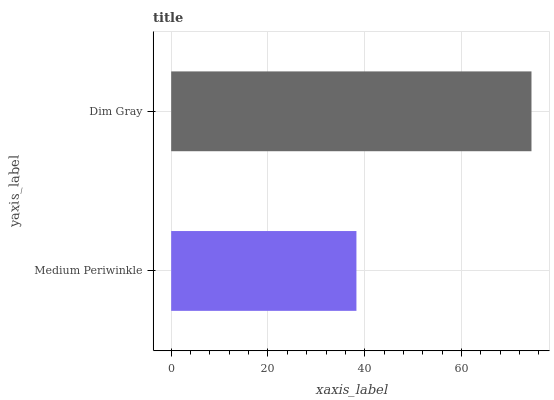Is Medium Periwinkle the minimum?
Answer yes or no. Yes. Is Dim Gray the maximum?
Answer yes or no. Yes. Is Dim Gray the minimum?
Answer yes or no. No. Is Dim Gray greater than Medium Periwinkle?
Answer yes or no. Yes. Is Medium Periwinkle less than Dim Gray?
Answer yes or no. Yes. Is Medium Periwinkle greater than Dim Gray?
Answer yes or no. No. Is Dim Gray less than Medium Periwinkle?
Answer yes or no. No. Is Dim Gray the high median?
Answer yes or no. Yes. Is Medium Periwinkle the low median?
Answer yes or no. Yes. Is Medium Periwinkle the high median?
Answer yes or no. No. Is Dim Gray the low median?
Answer yes or no. No. 